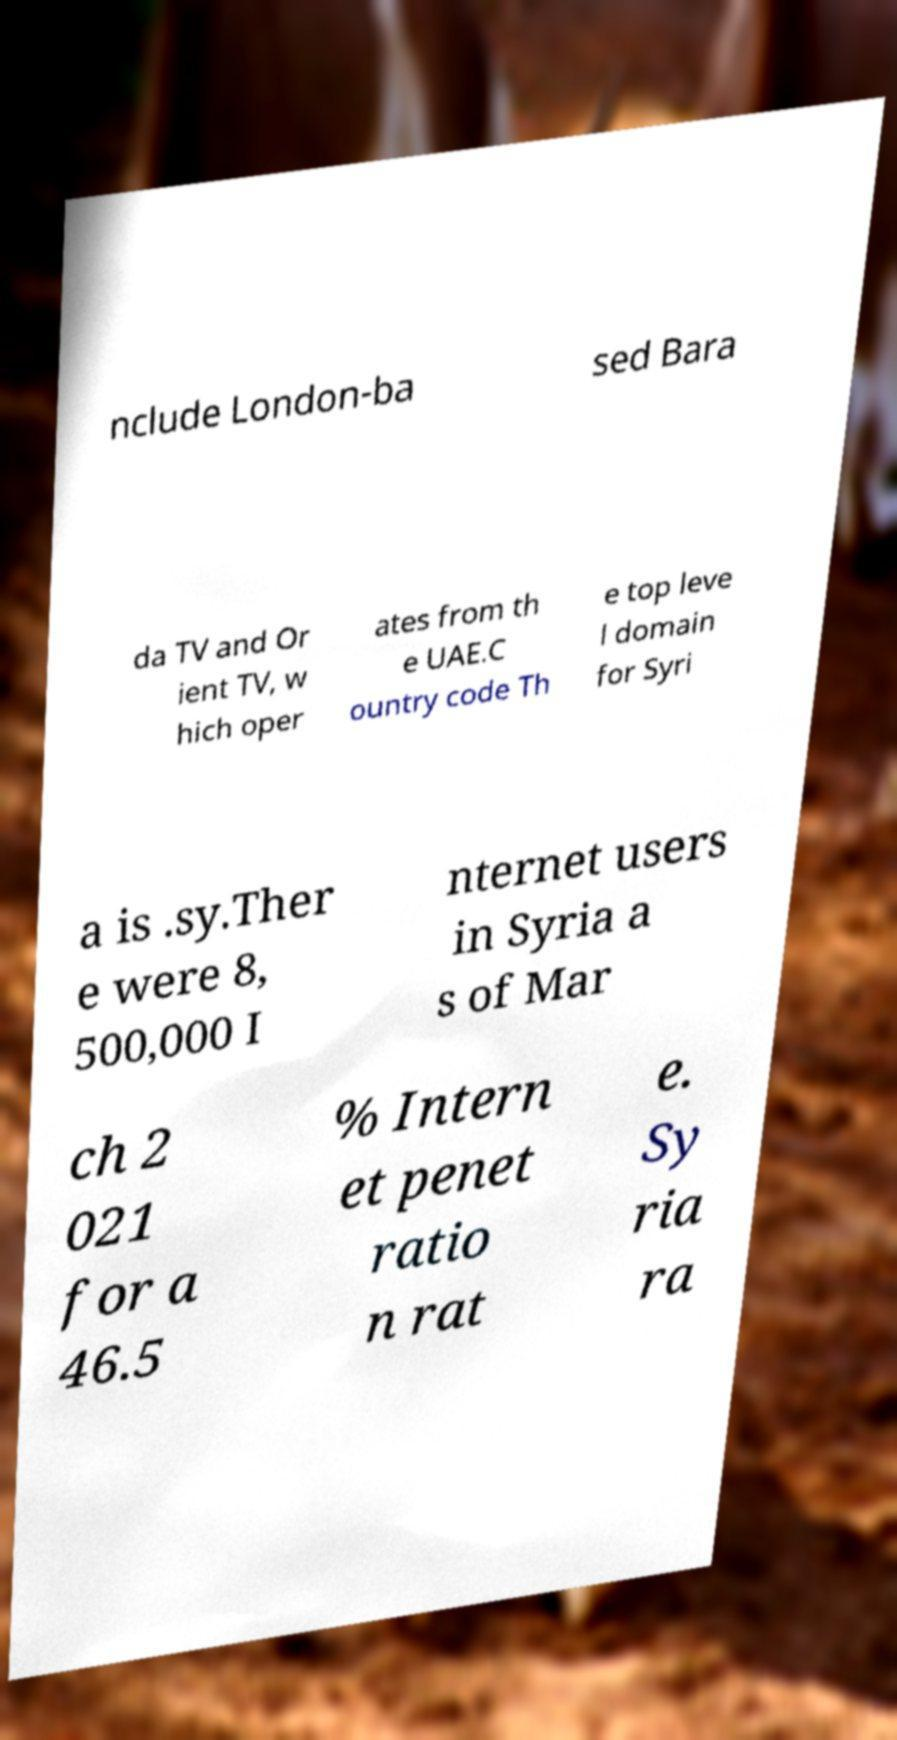Please read and relay the text visible in this image. What does it say? nclude London-ba sed Bara da TV and Or ient TV, w hich oper ates from th e UAE.C ountry code Th e top leve l domain for Syri a is .sy.Ther e were 8, 500,000 I nternet users in Syria a s of Mar ch 2 021 for a 46.5 % Intern et penet ratio n rat e. Sy ria ra 